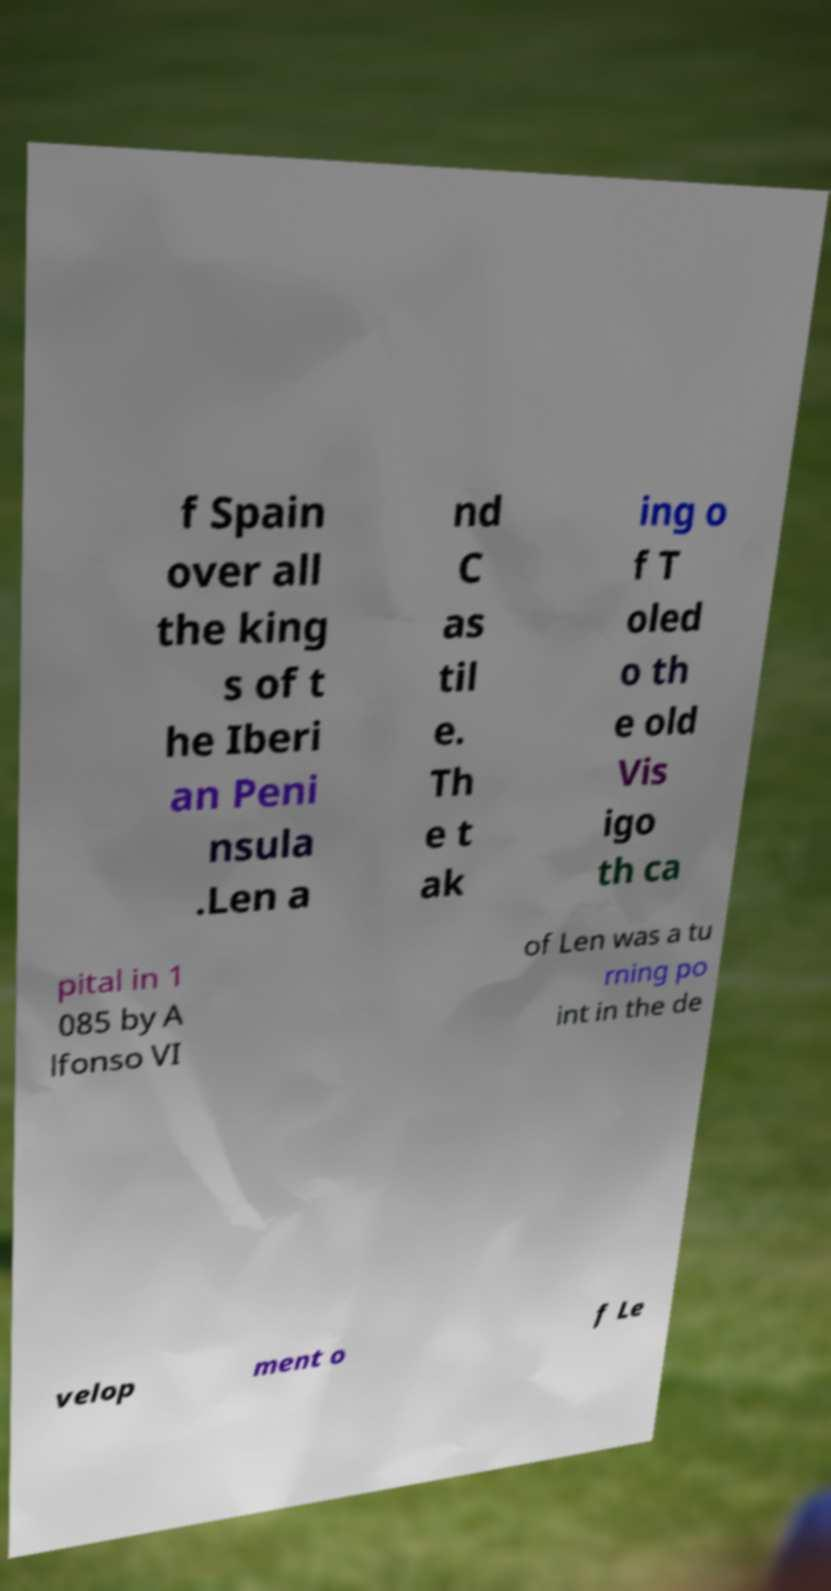Could you assist in decoding the text presented in this image and type it out clearly? f Spain over all the king s of t he Iberi an Peni nsula .Len a nd C as til e. Th e t ak ing o f T oled o th e old Vis igo th ca pital in 1 085 by A lfonso VI of Len was a tu rning po int in the de velop ment o f Le 